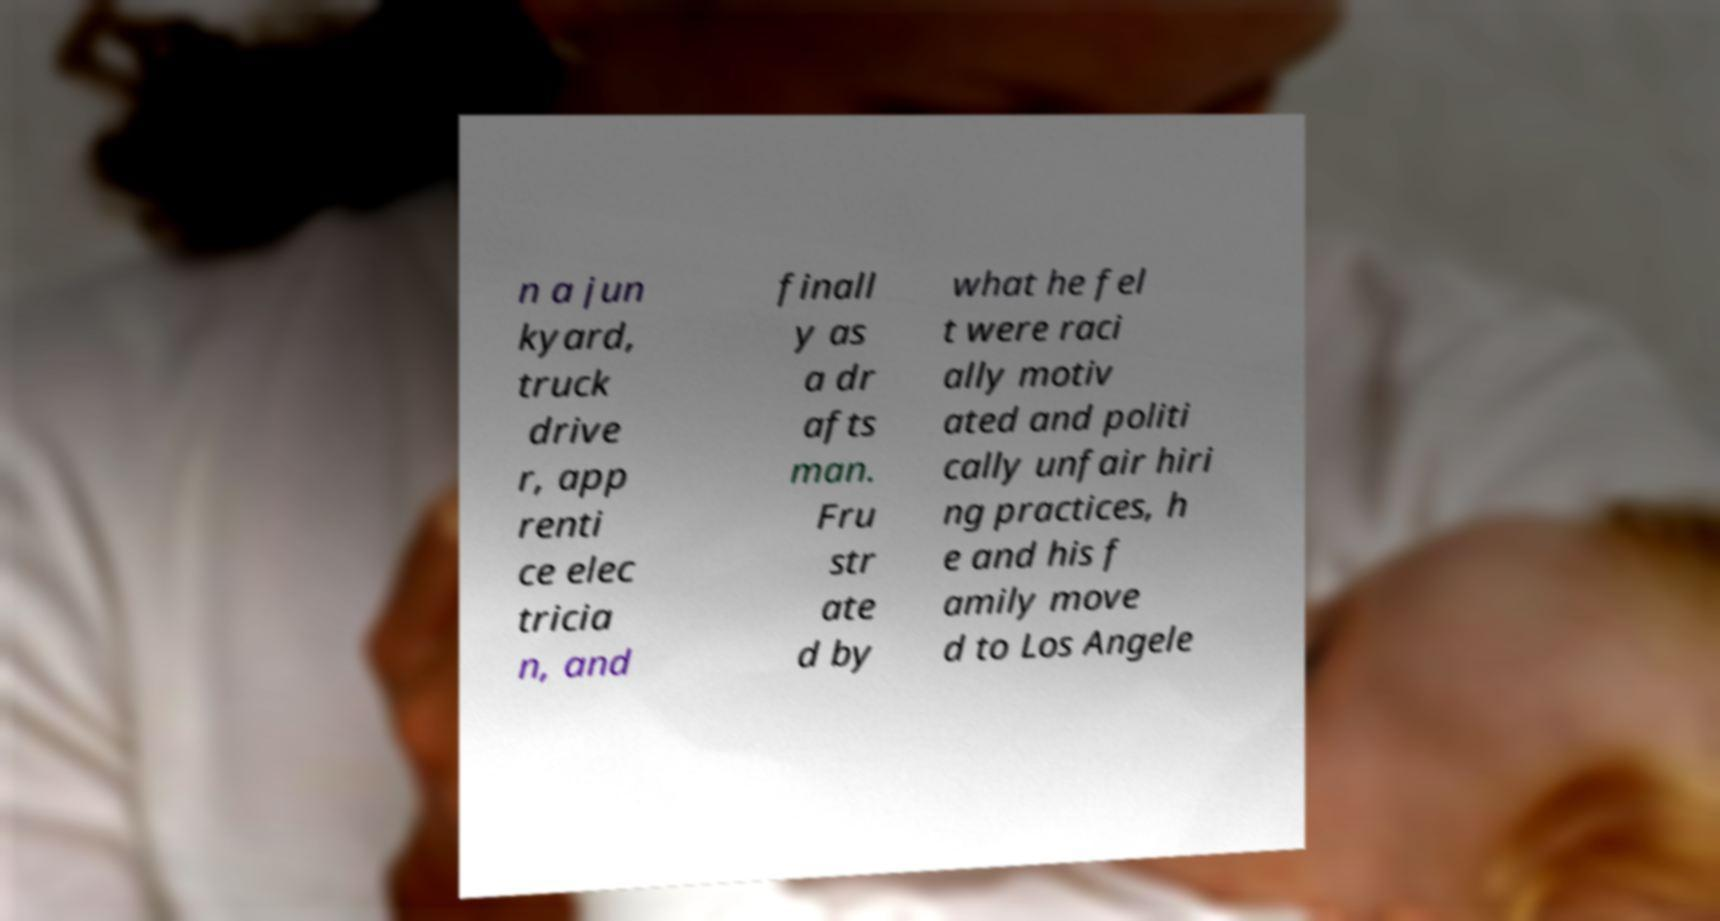I need the written content from this picture converted into text. Can you do that? n a jun kyard, truck drive r, app renti ce elec tricia n, and finall y as a dr afts man. Fru str ate d by what he fel t were raci ally motiv ated and politi cally unfair hiri ng practices, h e and his f amily move d to Los Angele 